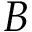<formula> <loc_0><loc_0><loc_500><loc_500>B</formula> 